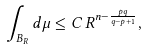Convert formula to latex. <formula><loc_0><loc_0><loc_500><loc_500>\int _ { B _ { R } } d \mu \leq C \, R ^ { n - \frac { p q } { q - p + 1 } } ,</formula> 